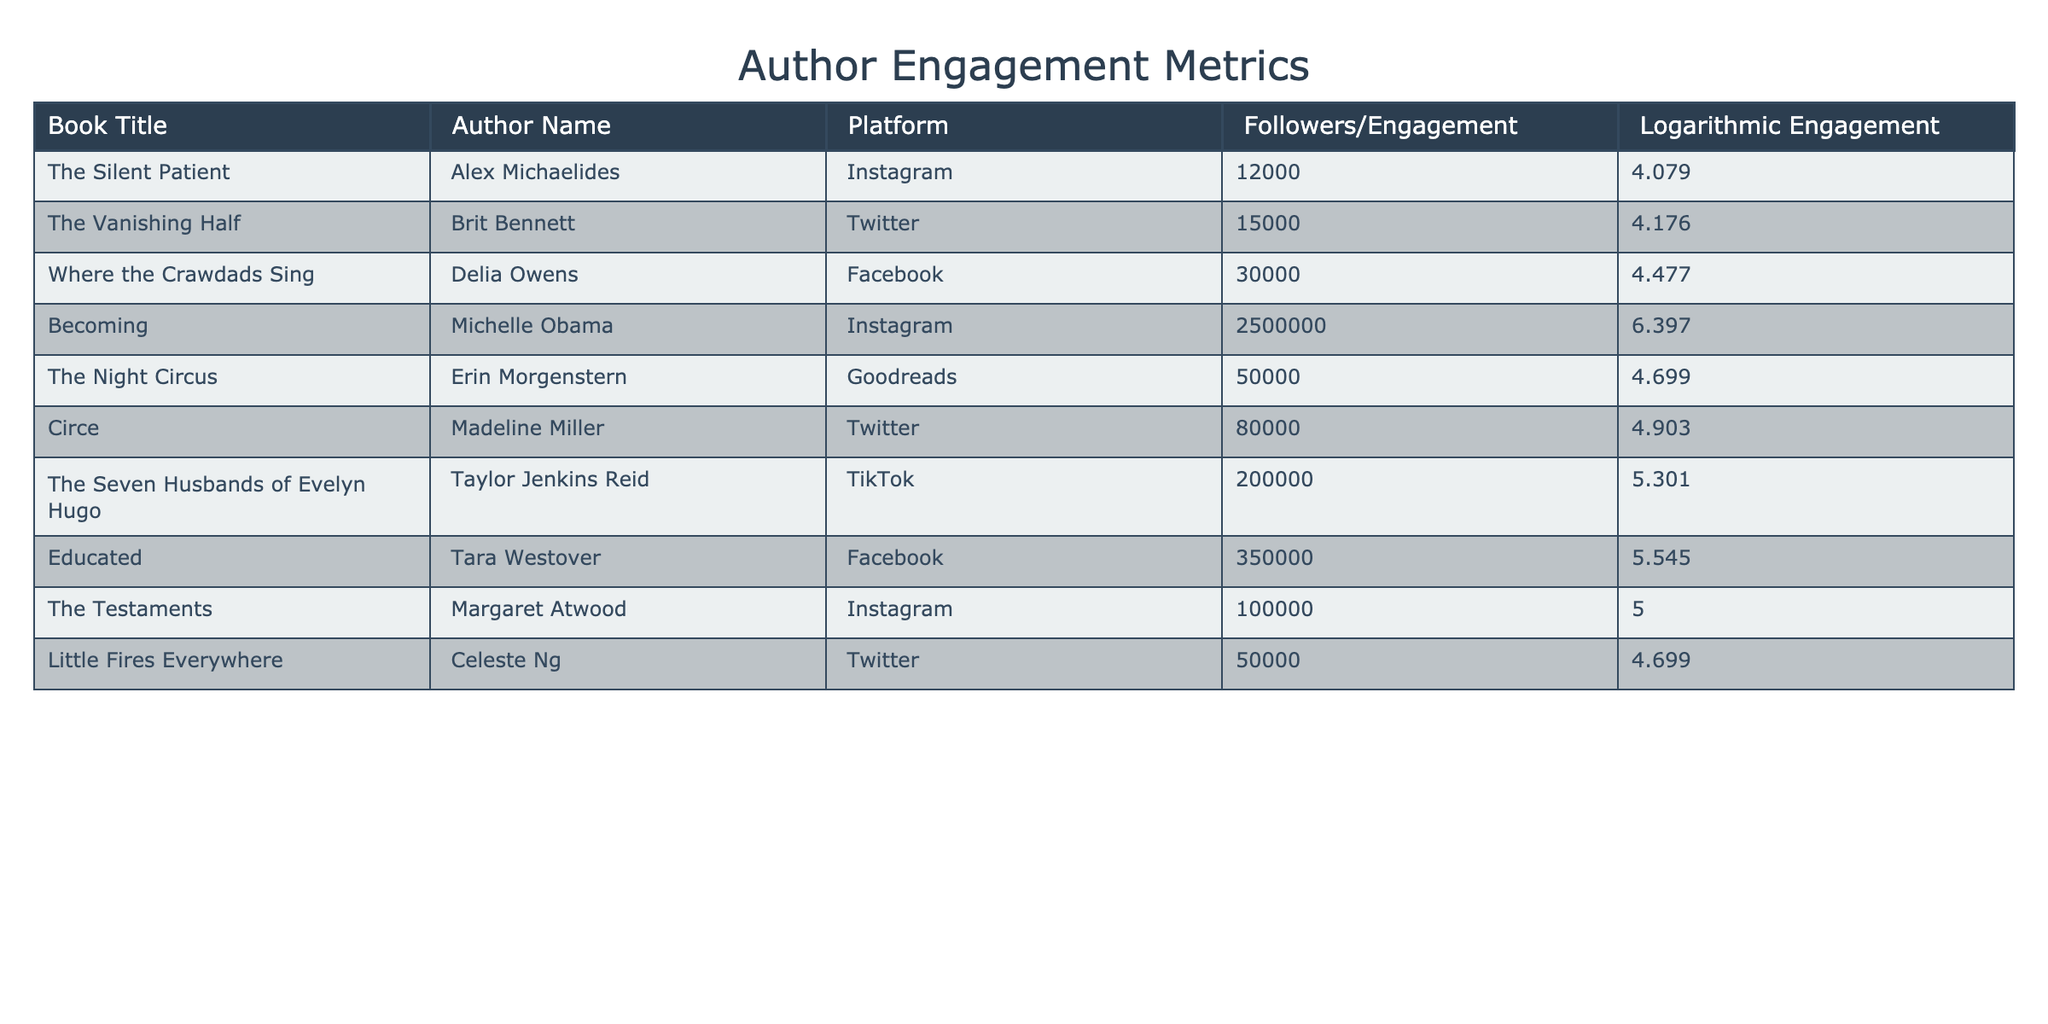What is the logarithmic engagement of "The Silent Patient"? The logarithmic engagement is directly provided in the table for each book. For "The Silent Patient", it is listed as 4.079.
Answer: 4.079 Which book has the highest follower engagement on Instagram? By examining the table, "Becoming" by Michelle Obama shows the highest engagement on Instagram with 2,500,000 followers.
Answer: "Becoming" Is "Where the Crawdads Sing" the most highly engaged book among all platforms? To determine this, we compare the logarithmic engagement values for all books. "Where the Crawdads Sing" has a logarithmic engagement of 4.477, which is not the highest. "Becoming" has the highest logarithmic engagement of 6.397.
Answer: No What is the total logarithmic engagement of all books on Twitter? The logarithmic engagement for books on Twitter are as follows: "The Vanishing Half" (4.176), "Circe" (4.903), and "Little Fires Everywhere" (4.699). Adding these gives 4.176 + 4.903 + 4.699 = 13.778.
Answer: 13.778 Which platform has the book with the second highest logarithmic engagement? First, we identify the book with the highest logarithmic engagement: "Becoming" at 6.397 (Instagram). The second highest is "The Seven Husbands of Evelyn Hugo" at 5.301 (TikTok). So, the platform is TikTok.
Answer: TikTok How many books have an engagement logarithm above 5.0? We review the logarithmic engagement values: "Becoming" (6.397), "The Seven Husbands of Evelyn Hugo" (5.301), "Educated" (5.545), and "The Testaments" (5.000). This gives us 4 books above 5.0.
Answer: 4 Is the engagement of "Educated" higher than that of "The Night Circus"? The engagement of "Educated" is 5.545 while "The Night Circus" is at 4.699. Since 5.545 is greater than 4.699, "Educated" has higher engagement.
Answer: Yes What is the average logarithmic engagement of books released on Facebook? The books on Facebook are "Where the Crawdads Sing" (4.477) and "Educated" (5.545). The average computation is (4.477 + 5.545) / 2 = 5.011.
Answer: 5.011 Which author has higher engagement on social media: Delia Owens or Tara Westover? Delia Owens has a logarithmic engagement of 4.477 for "Where the Crawdads Sing" on Facebook, and Tara Westover has 5.545 for "Educated" on Facebook. Comparing these shows that Tara Westover has higher engagement.
Answer: Tara Westover 